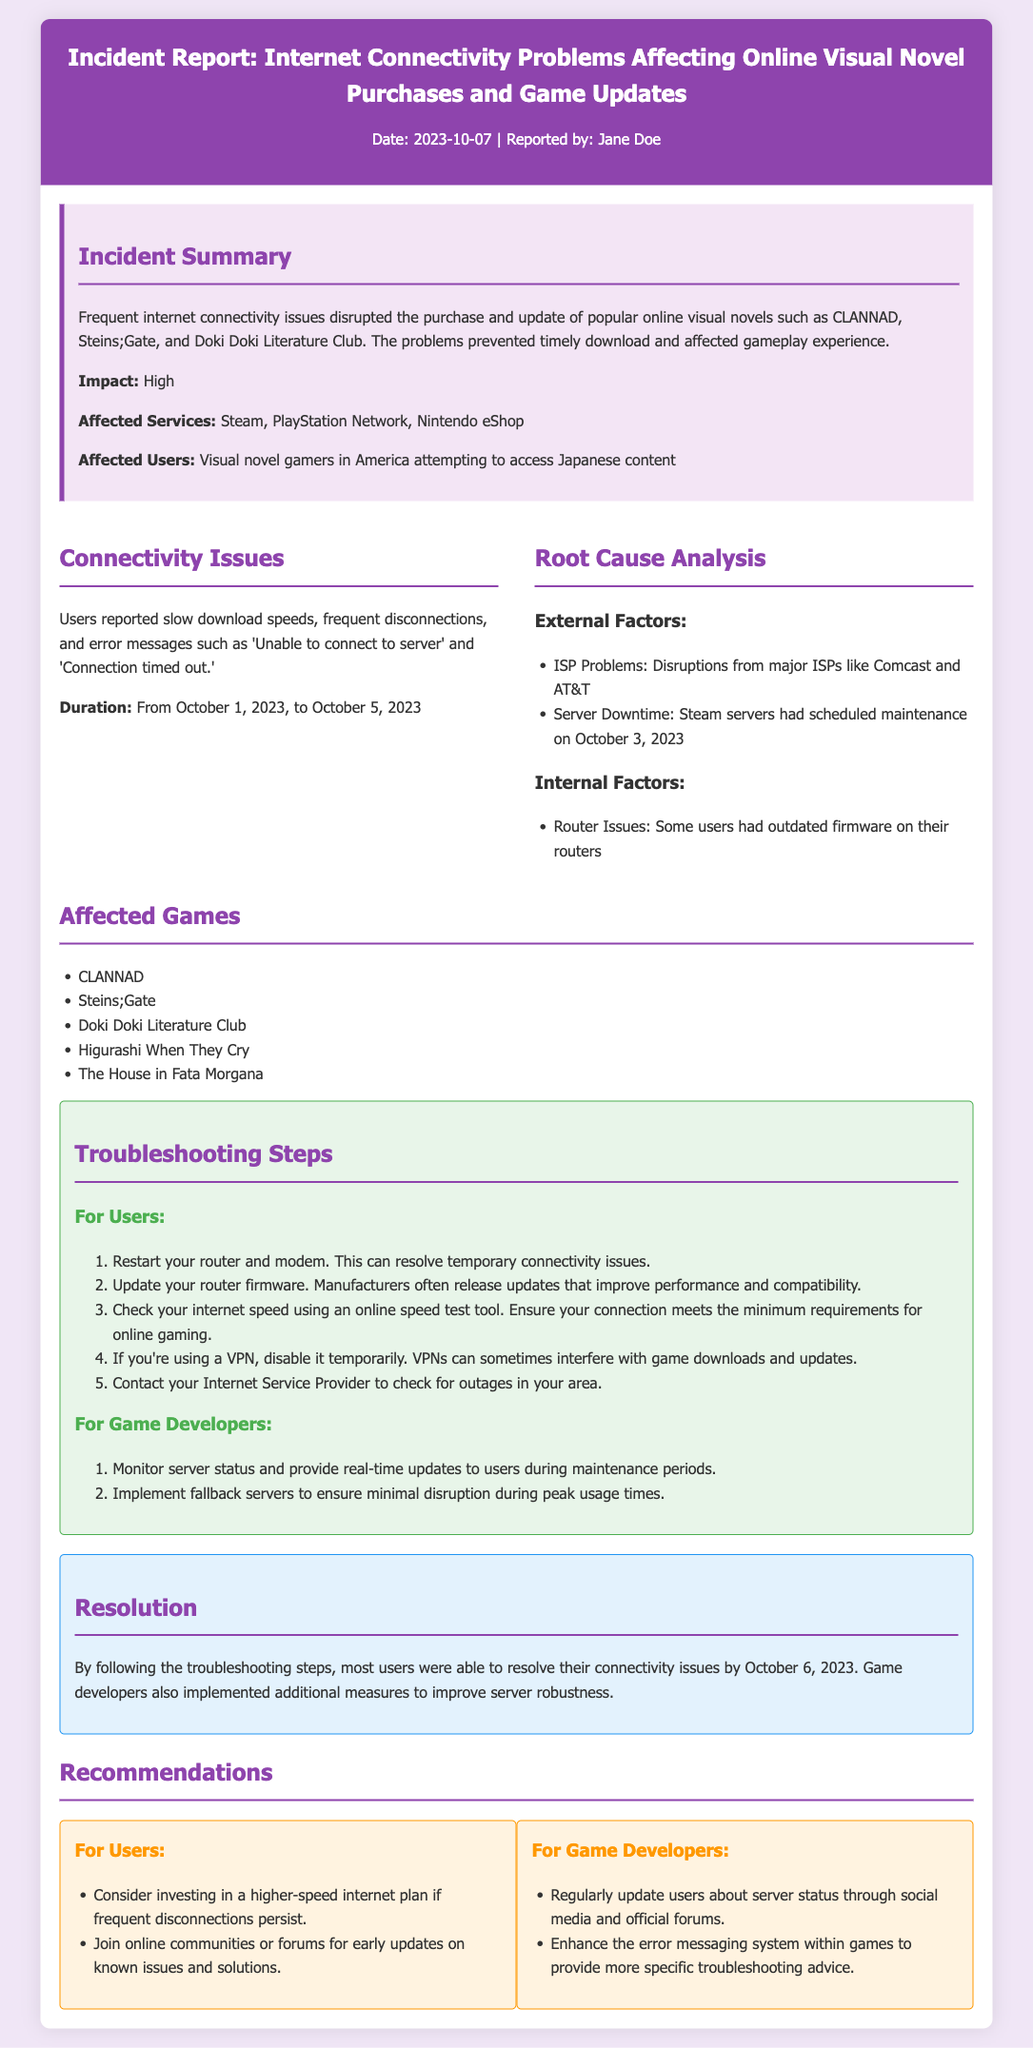What date was the incident reported? The date the incident was reported is stated at the top of the document.
Answer: 2023-10-07 What were the main affected services? The affected services are listed in the incident summary section.
Answer: Steam, PlayStation Network, Nintendo eShop How long did the connectivity issues last? The duration of the connectivity issues is specified in the connectivity issues section.
Answer: From October 1, 2023, to October 5, 2023 What did users experience during the connectivity issues? The document specifies the type of issues reported by users in the connectivity issues section.
Answer: Slow download speeds, frequent disconnections, error messages What is one troubleshooting step for users? A troubleshooting step for users is outlined in the troubleshooting steps section.
Answer: Restart your router and modem What was one external factor causing the issues? External factors contributing to the issues are discussed in the root cause analysis section.
Answer: ISP Problems: Disruptions from major ISPs like Comcast and AT&T What was implemented to resolve user connectivity issues? The resolution section discusses measures taken to address user issues.
Answer: Troubleshooting steps What is one recommendation for users regarding internet speed? The recommendations for users are mentioned in the recommendations section.
Answer: Consider investing in a higher-speed internet plan What was the root cause of the server downtime? The root cause of external factors affecting connectivity is provided in the root cause analysis section.
Answer: Steam servers had scheduled maintenance 